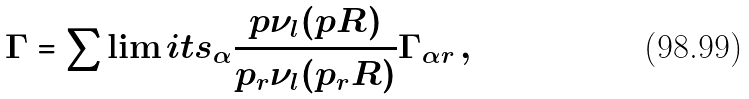Convert formula to latex. <formula><loc_0><loc_0><loc_500><loc_500>\Gamma = \sum \lim i t s _ { \alpha } \frac { p \nu _ { l } ( p R ) } { p _ { r } \nu _ { l } ( p _ { r } R ) } \Gamma _ { \alpha r } \, ,</formula> 